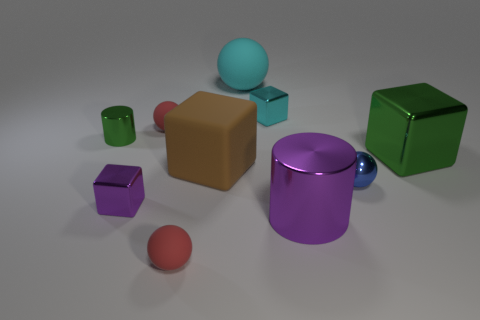Subtract all large matte cubes. How many cubes are left? 3 Subtract all green cylinders. How many cylinders are left? 1 Subtract all cylinders. How many objects are left? 8 Subtract all brown blocks. Subtract all gray cylinders. How many blocks are left? 3 Subtract all purple cylinders. How many cyan blocks are left? 1 Subtract 1 purple blocks. How many objects are left? 9 Subtract 2 spheres. How many spheres are left? 2 Subtract all big brown objects. Subtract all purple shiny things. How many objects are left? 7 Add 5 metallic cubes. How many metallic cubes are left? 8 Add 4 big green blocks. How many big green blocks exist? 5 